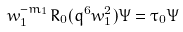<formula> <loc_0><loc_0><loc_500><loc_500>w _ { 1 } ^ { - m _ { 1 } } R _ { 0 } ( q ^ { 6 } w _ { 1 } ^ { 2 } ) \Psi = \tau _ { 0 } \Psi</formula> 